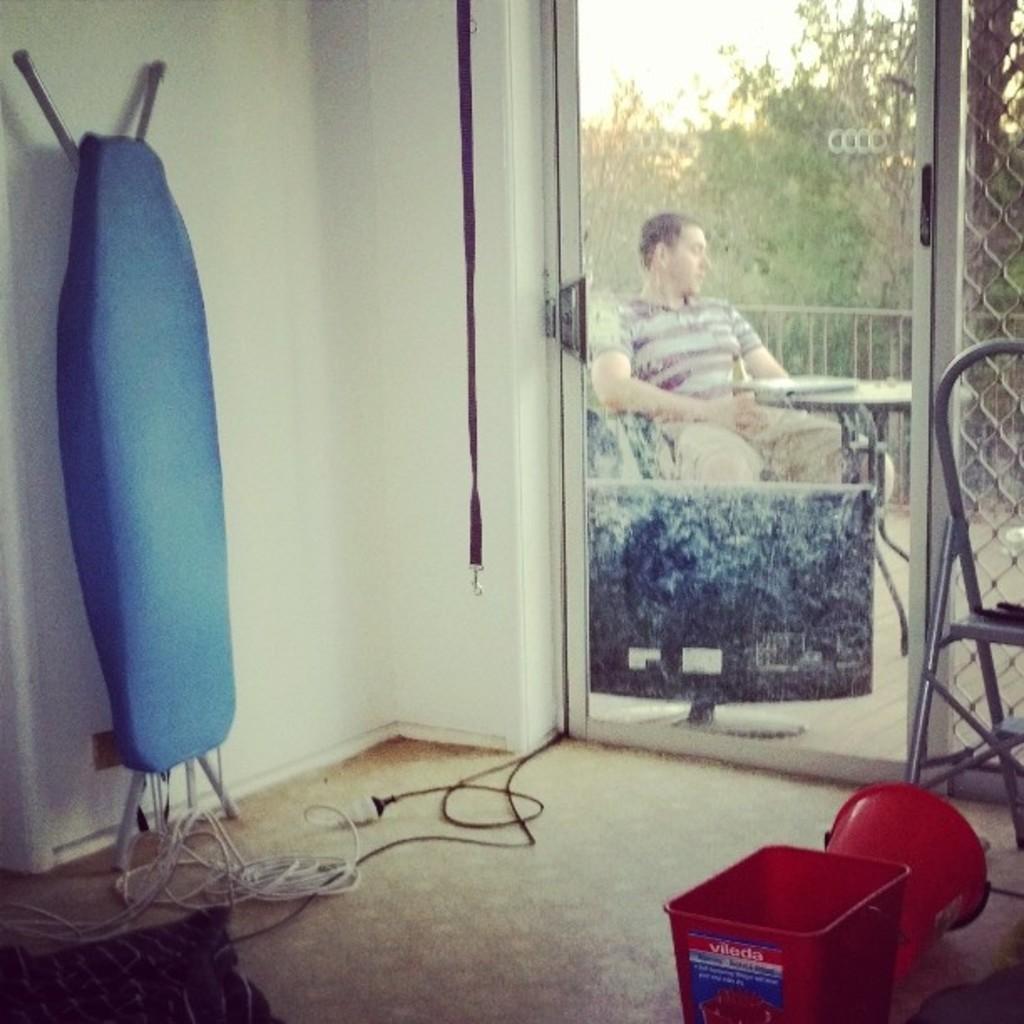Describe this image in one or two sentences. This image is taken indoors. At the bottom of the image there is a floor. In the middle of the image there is a bucket and a basket on a floor. There is a chair. There are a few wires and an iron table on the floor. In the background there is a wall with a glass door. Through the glass door we can see there are a few trees. There is a railing. A man is sitting in the chair. There is a table with a few things on it and there is a television. 